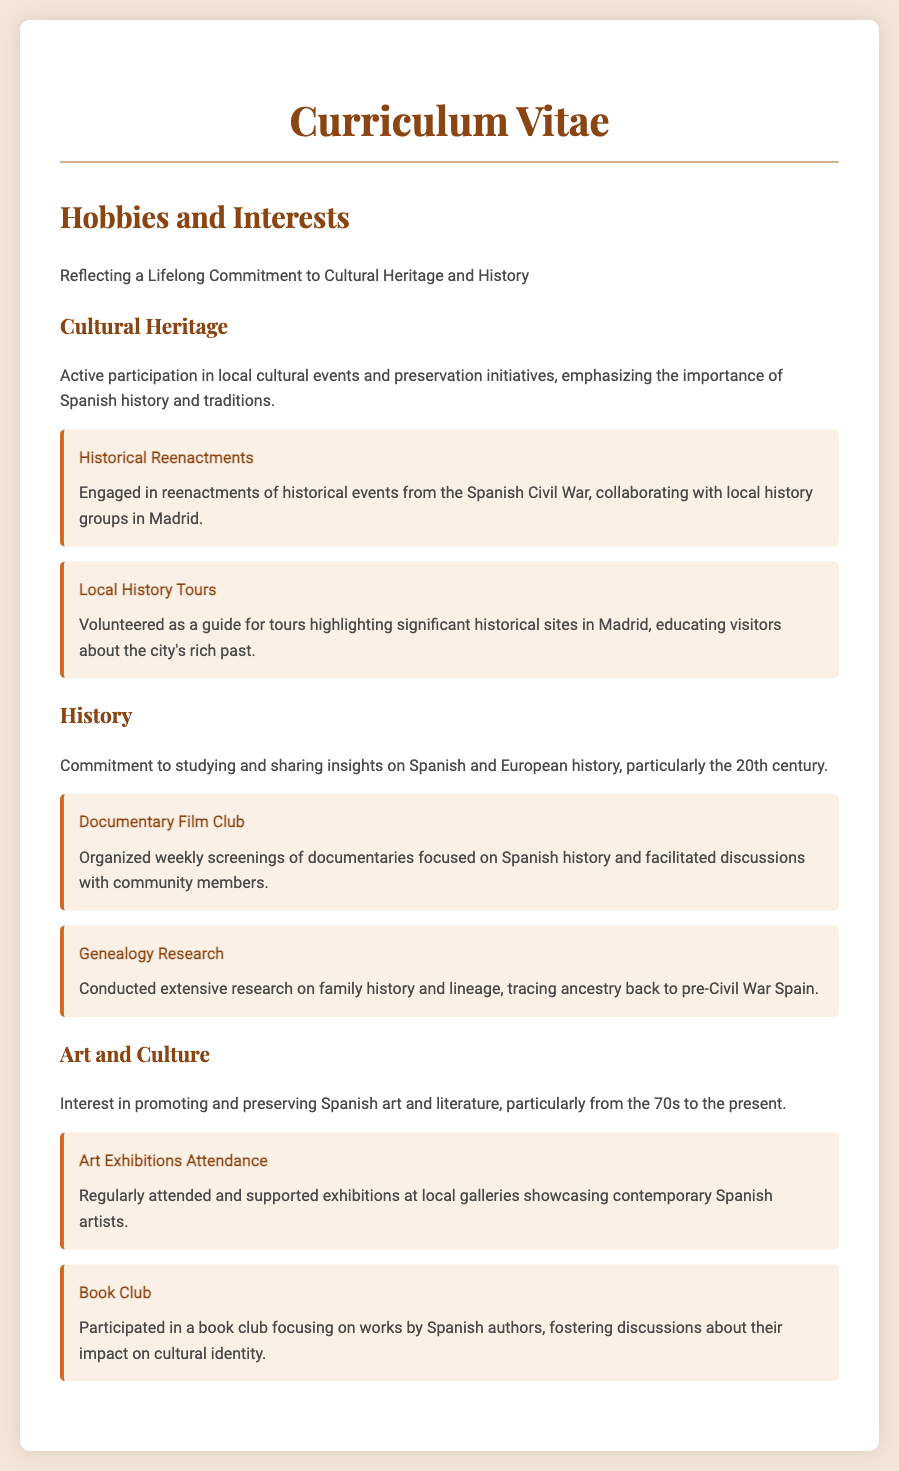What hobbies does the individual engage in? The hobbies listed include cultural heritage activities, historical studies, and art and culture interests, emphasizing a commitment to cultural heritage and history.
Answer: Cultural Heritage, History, Art and Culture How does the individual participate in local cultural events? The individual is actively involved in local cultural events and preservation initiatives, particularly focusing on Spanish history and traditions.
Answer: Active participation What type of historical reenactments does the individual engage in? The individual is engaged in reenactments of events specifically from the Spanish Civil War, collaborating with local history groups.
Answer: Spanish Civil War What is the purpose of the local history tours the individual volunteered for? The purpose is to educate visitors about significant historical sites in Madrid, enhancing their understanding of the city's rich past.
Answer: Educating visitors How often does the individual organize documentary screenings? The individual organizes weekly screenings of documentaries that focus on Spanish history.
Answer: Weekly What area of family research does the individual focus on? The individual has conducted extensive research specifically on family history and lineage tracing back to pre-Civil War Spain.
Answer: Family history and lineage Name one type of event the individual regularly attends related to art. The individual regularly attends exhibitions showcasing contemporary Spanish artists.
Answer: Art Exhibitions What literary activity does the individual participate in? The individual participates in a book club dedicated to discussing works by Spanish authors.
Answer: Book Club 